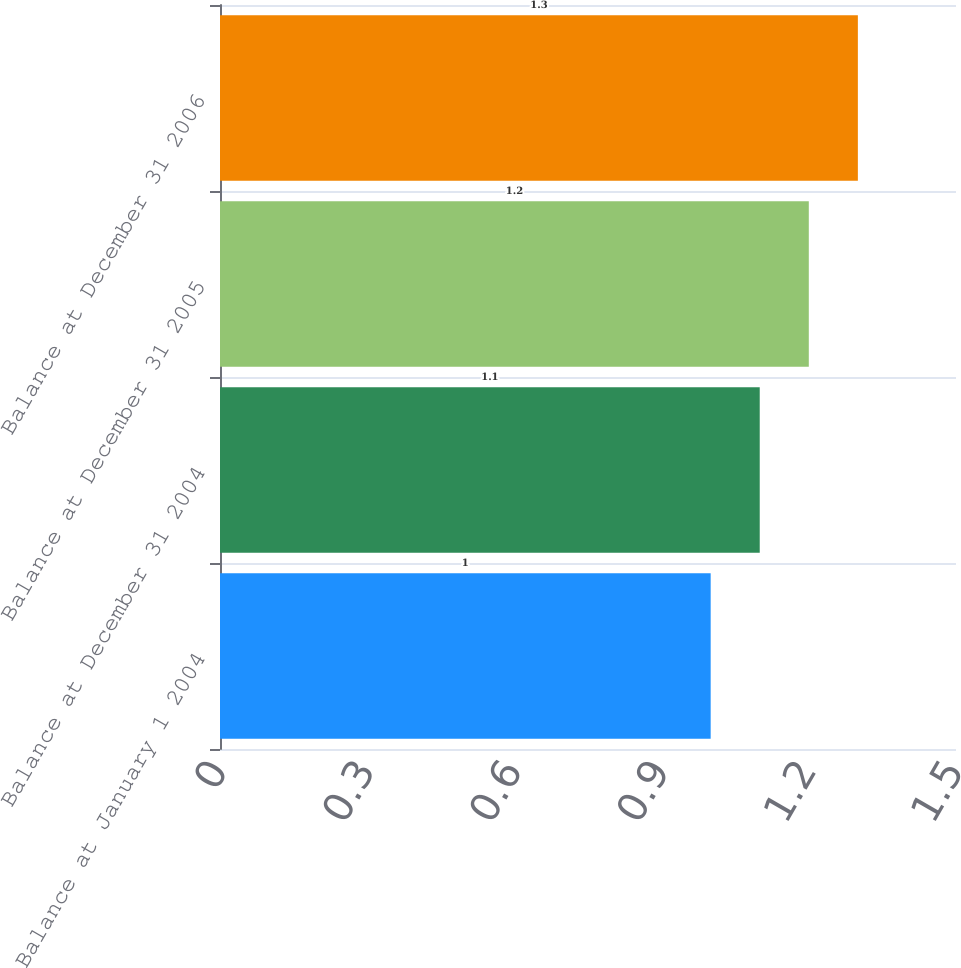Convert chart. <chart><loc_0><loc_0><loc_500><loc_500><bar_chart><fcel>Balance at January 1 2004<fcel>Balance at December 31 2004<fcel>Balance at December 31 2005<fcel>Balance at December 31 2006<nl><fcel>1<fcel>1.1<fcel>1.2<fcel>1.3<nl></chart> 